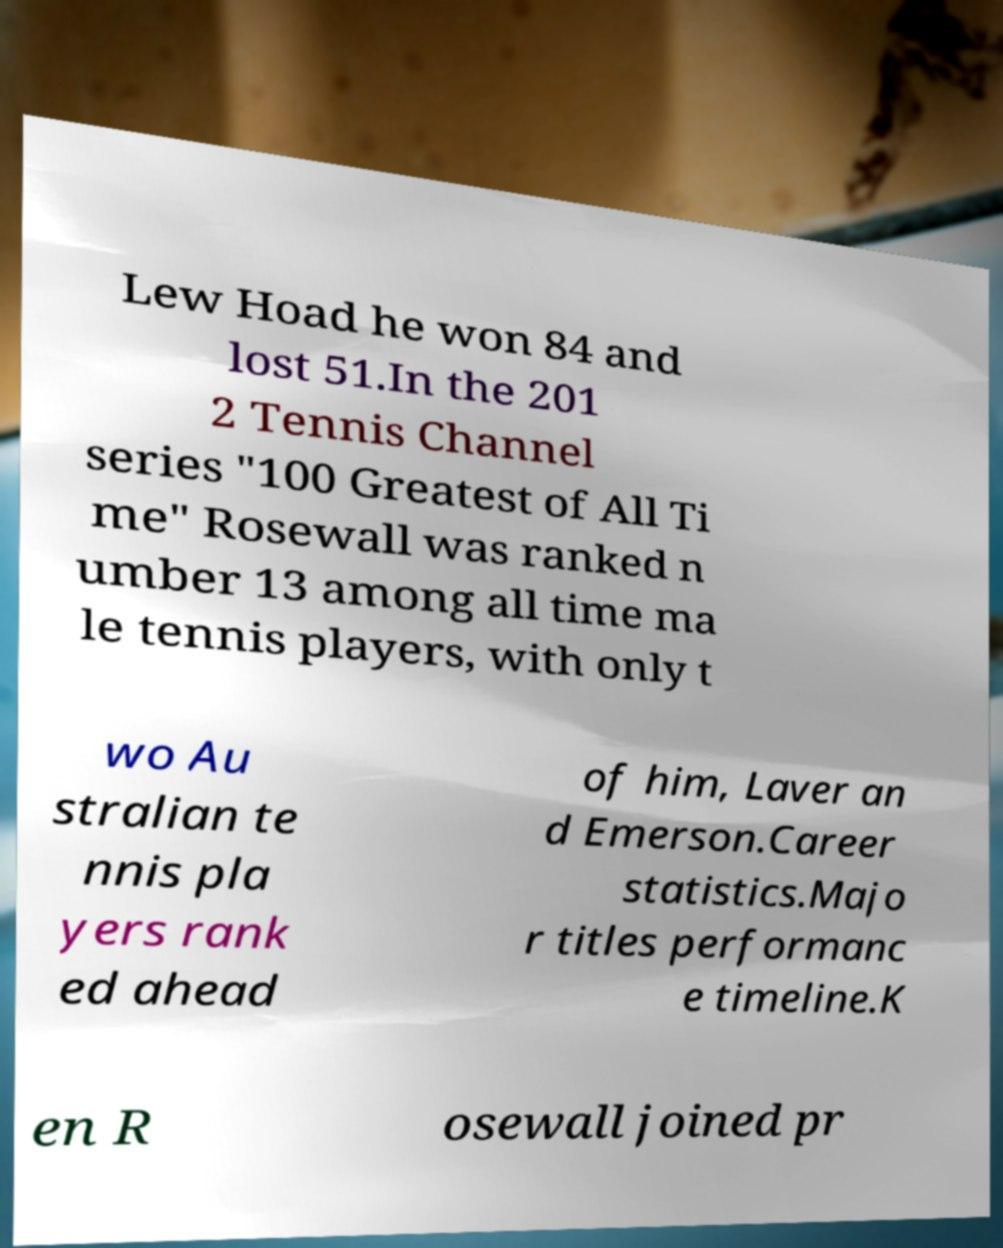Please identify and transcribe the text found in this image. Lew Hoad he won 84 and lost 51.In the 201 2 Tennis Channel series "100 Greatest of All Ti me" Rosewall was ranked n umber 13 among all time ma le tennis players, with only t wo Au stralian te nnis pla yers rank ed ahead of him, Laver an d Emerson.Career statistics.Majo r titles performanc e timeline.K en R osewall joined pr 